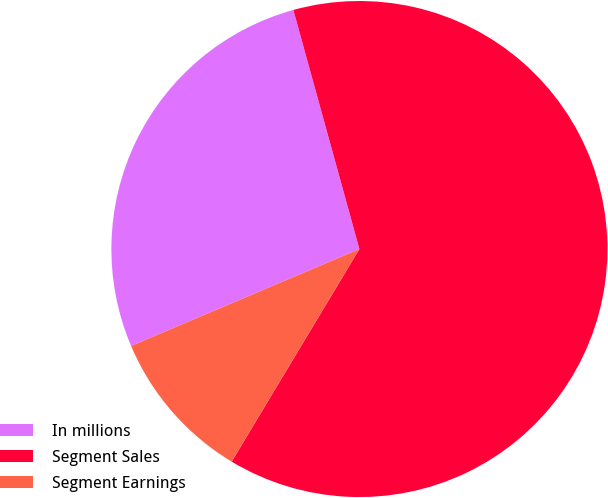Convert chart to OTSL. <chart><loc_0><loc_0><loc_500><loc_500><pie_chart><fcel>In millions<fcel>Segment Sales<fcel>Segment Earnings<nl><fcel>27.1%<fcel>62.9%<fcel>10.0%<nl></chart> 